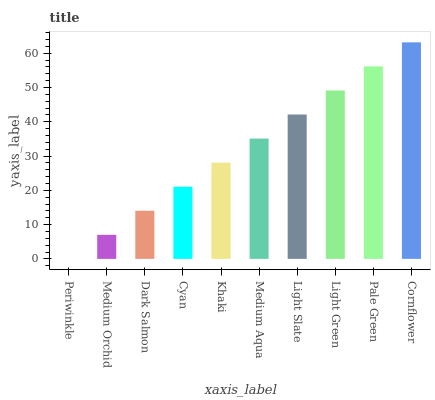Is Periwinkle the minimum?
Answer yes or no. Yes. Is Cornflower the maximum?
Answer yes or no. Yes. Is Medium Orchid the minimum?
Answer yes or no. No. Is Medium Orchid the maximum?
Answer yes or no. No. Is Medium Orchid greater than Periwinkle?
Answer yes or no. Yes. Is Periwinkle less than Medium Orchid?
Answer yes or no. Yes. Is Periwinkle greater than Medium Orchid?
Answer yes or no. No. Is Medium Orchid less than Periwinkle?
Answer yes or no. No. Is Medium Aqua the high median?
Answer yes or no. Yes. Is Khaki the low median?
Answer yes or no. Yes. Is Medium Orchid the high median?
Answer yes or no. No. Is Periwinkle the low median?
Answer yes or no. No. 